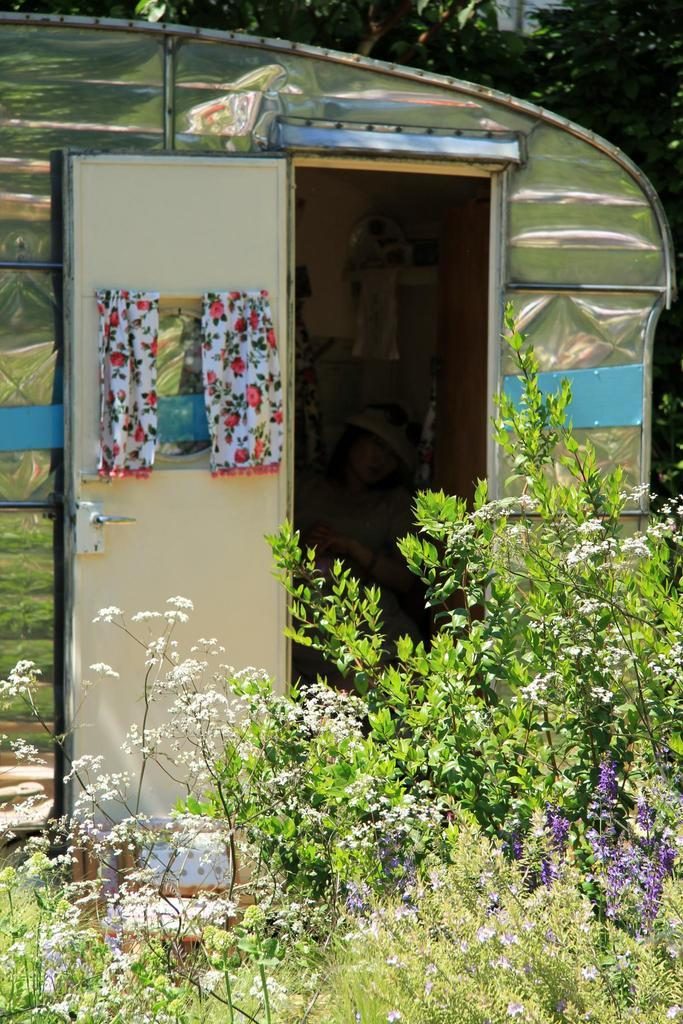What type of living organisms can be seen in the image? Plants can be seen in the image. What structure is located behind the plants? There is a tent house behind the plants. Who is present in the tent house? A woman is sitting in the tent house. What type of vegetable is being washed at the faucet in the image? There is no faucet or vegetable present in the image. 